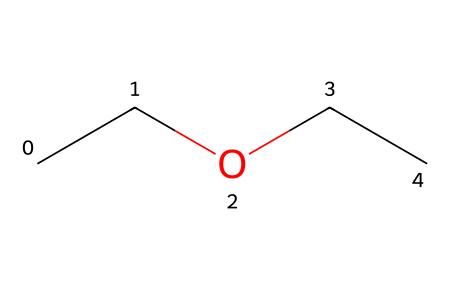What is the molecular formula of the compound? The SMILES code "CCOCC" represents a molecular structure with 4 carbon (C) atoms and 10 hydrogen (H) atoms, leading to the molecular formula C4H10O.
Answer: C4H10O How many oxygen atoms are present in the molecule? Analyzing the SMILES representation, only one oxygen (O) atom is present between two ethyl groups, indicating its existence in the structure.
Answer: 1 What type of functional group does this molecule contain? The presence of an ether bond (R-O-R') indicated by the oxygen atom situated between the two carbon chains identifies this molecule as an ether.
Answer: ether What is the number of carbon atoms in the molecule? By examining the SMILES notation, the "CC" at the beginning and "CC" at the end shows there are four carbon atoms in total.
Answer: 4 What is the degree of branching in the molecule? The molecule has a linear structure with the carbon chains connected through the ether functional group, indicating zero degrees of branching.
Answer: 0 What type of interactions might ethoxyethane facilitate in data storage solutions? Ethoxyethane, as an ether, can form hydrogen bonds due to the oxygen atom, influencing its solubility and interaction with other substances in data storage solutions.
Answer: hydrogen bonds 